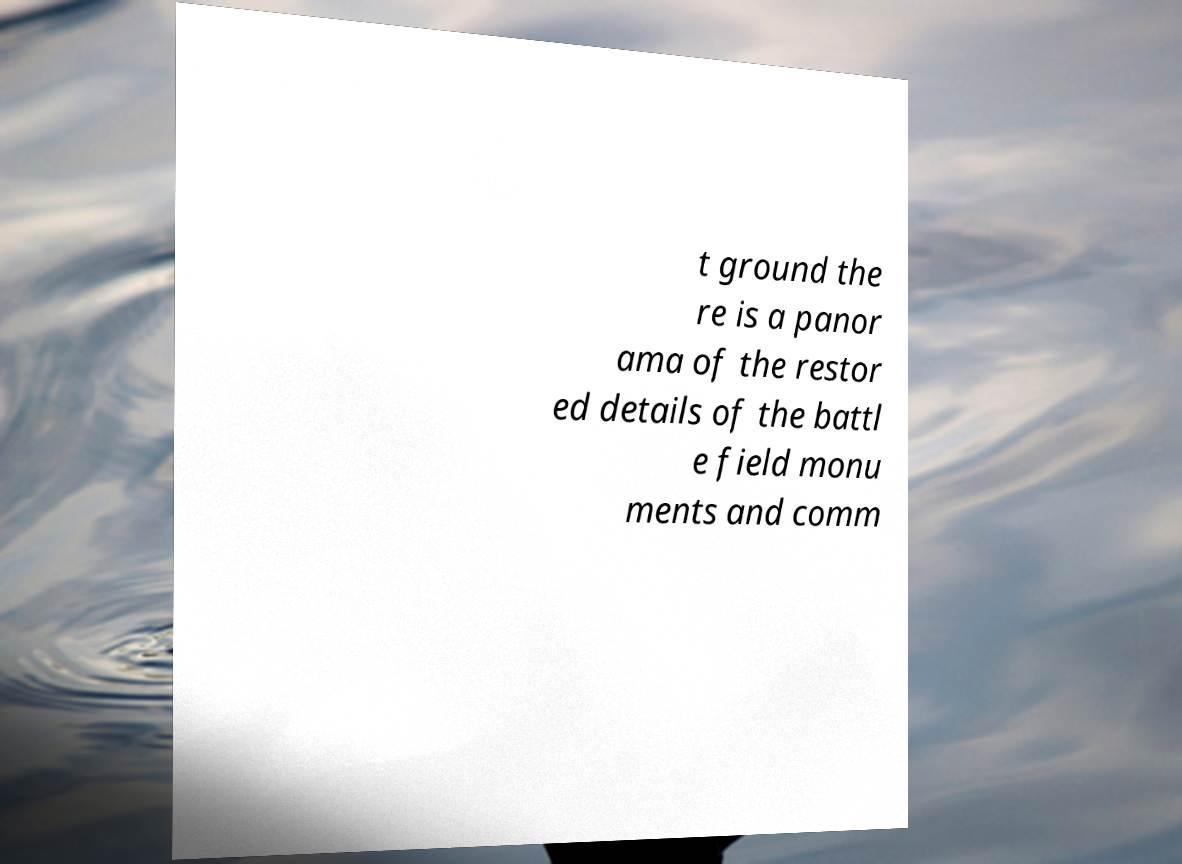What messages or text are displayed in this image? I need them in a readable, typed format. t ground the re is a panor ama of the restor ed details of the battl e field monu ments and comm 